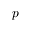<formula> <loc_0><loc_0><loc_500><loc_500>p</formula> 